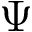<formula> <loc_0><loc_0><loc_500><loc_500>\Psi</formula> 